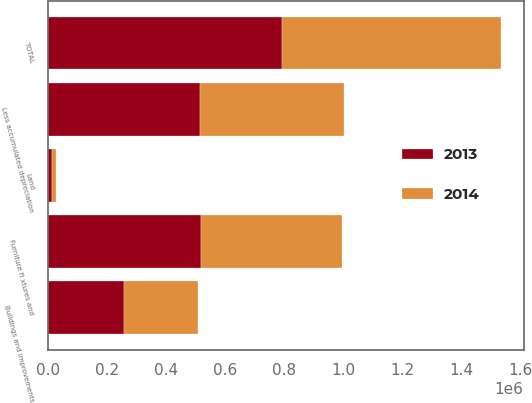Convert chart. <chart><loc_0><loc_0><loc_500><loc_500><stacked_bar_chart><ecel><fcel>Land<fcel>Buildings and improvements<fcel>Furniture fi xtures and<fcel>TOTAL<fcel>Less accumulated depreciation<nl><fcel>2013<fcel>14359<fcel>258680<fcel>519146<fcel>792185<fcel>514540<nl><fcel>2014<fcel>14359<fcel>249034<fcel>477617<fcel>741010<fcel>487380<nl></chart> 